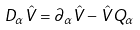<formula> <loc_0><loc_0><loc_500><loc_500>D _ { \alpha } \hat { V } = \partial _ { \alpha } \hat { V } - \hat { V } Q _ { \alpha }</formula> 